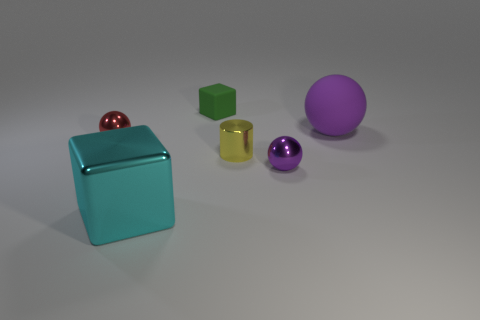Subtract all purple balls. How many were subtracted if there are1purple balls left? 1 Subtract all purple cylinders. How many purple balls are left? 2 Subtract all tiny metallic spheres. How many spheres are left? 1 Add 2 red shiny spheres. How many objects exist? 8 Subtract all cylinders. How many objects are left? 5 Add 3 tiny green things. How many tiny green things are left? 4 Add 6 cylinders. How many cylinders exist? 7 Subtract 0 blue blocks. How many objects are left? 6 Subtract all yellow cubes. Subtract all green balls. How many cubes are left? 2 Subtract all tiny purple matte balls. Subtract all tiny green objects. How many objects are left? 5 